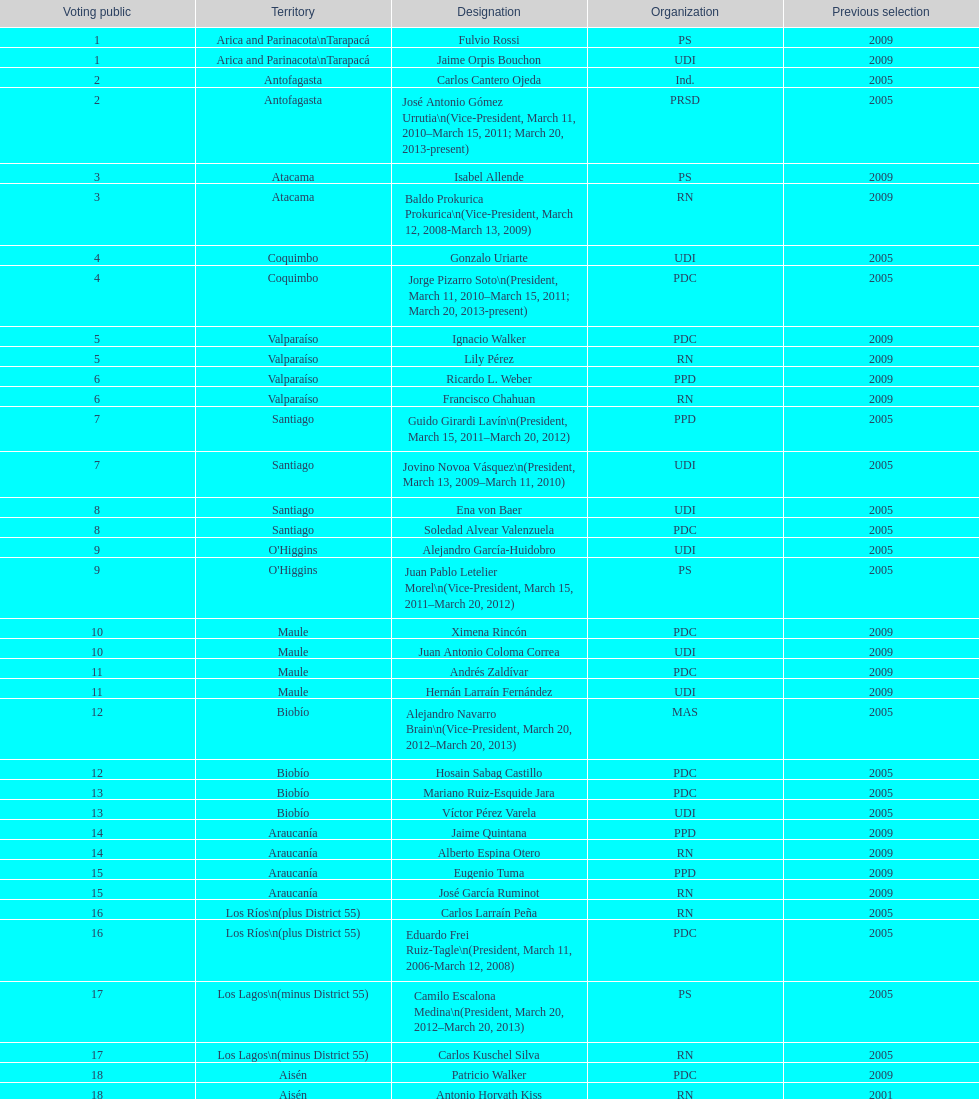Parse the full table. {'header': ['Voting public', 'Territory', 'Designation', 'Organization', 'Previous selection'], 'rows': [['1', 'Arica and Parinacota\\nTarapacá', 'Fulvio Rossi', 'PS', '2009'], ['1', 'Arica and Parinacota\\nTarapacá', 'Jaime Orpis Bouchon', 'UDI', '2009'], ['2', 'Antofagasta', 'Carlos Cantero Ojeda', 'Ind.', '2005'], ['2', 'Antofagasta', 'José Antonio Gómez Urrutia\\n(Vice-President, March 11, 2010–March 15, 2011; March 20, 2013-present)', 'PRSD', '2005'], ['3', 'Atacama', 'Isabel Allende', 'PS', '2009'], ['3', 'Atacama', 'Baldo Prokurica Prokurica\\n(Vice-President, March 12, 2008-March 13, 2009)', 'RN', '2009'], ['4', 'Coquimbo', 'Gonzalo Uriarte', 'UDI', '2005'], ['4', 'Coquimbo', 'Jorge Pizarro Soto\\n(President, March 11, 2010–March 15, 2011; March 20, 2013-present)', 'PDC', '2005'], ['5', 'Valparaíso', 'Ignacio Walker', 'PDC', '2009'], ['5', 'Valparaíso', 'Lily Pérez', 'RN', '2009'], ['6', 'Valparaíso', 'Ricardo L. Weber', 'PPD', '2009'], ['6', 'Valparaíso', 'Francisco Chahuan', 'RN', '2009'], ['7', 'Santiago', 'Guido Girardi Lavín\\n(President, March 15, 2011–March 20, 2012)', 'PPD', '2005'], ['7', 'Santiago', 'Jovino Novoa Vásquez\\n(President, March 13, 2009–March 11, 2010)', 'UDI', '2005'], ['8', 'Santiago', 'Ena von Baer', 'UDI', '2005'], ['8', 'Santiago', 'Soledad Alvear Valenzuela', 'PDC', '2005'], ['9', "O'Higgins", 'Alejandro García-Huidobro', 'UDI', '2005'], ['9', "O'Higgins", 'Juan Pablo Letelier Morel\\n(Vice-President, March 15, 2011–March 20, 2012)', 'PS', '2005'], ['10', 'Maule', 'Ximena Rincón', 'PDC', '2009'], ['10', 'Maule', 'Juan Antonio Coloma Correa', 'UDI', '2009'], ['11', 'Maule', 'Andrés Zaldívar', 'PDC', '2009'], ['11', 'Maule', 'Hernán Larraín Fernández', 'UDI', '2009'], ['12', 'Biobío', 'Alejandro Navarro Brain\\n(Vice-President, March 20, 2012–March 20, 2013)', 'MAS', '2005'], ['12', 'Biobío', 'Hosain Sabag Castillo', 'PDC', '2005'], ['13', 'Biobío', 'Mariano Ruiz-Esquide Jara', 'PDC', '2005'], ['13', 'Biobío', 'Víctor Pérez Varela', 'UDI', '2005'], ['14', 'Araucanía', 'Jaime Quintana', 'PPD', '2009'], ['14', 'Araucanía', 'Alberto Espina Otero', 'RN', '2009'], ['15', 'Araucanía', 'Eugenio Tuma', 'PPD', '2009'], ['15', 'Araucanía', 'José García Ruminot', 'RN', '2009'], ['16', 'Los Ríos\\n(plus District 55)', 'Carlos Larraín Peña', 'RN', '2005'], ['16', 'Los Ríos\\n(plus District 55)', 'Eduardo Frei Ruiz-Tagle\\n(President, March 11, 2006-March 12, 2008)', 'PDC', '2005'], ['17', 'Los Lagos\\n(minus District 55)', 'Camilo Escalona Medina\\n(President, March 20, 2012–March 20, 2013)', 'PS', '2005'], ['17', 'Los Lagos\\n(minus District 55)', 'Carlos Kuschel Silva', 'RN', '2005'], ['18', 'Aisén', 'Patricio Walker', 'PDC', '2009'], ['18', 'Aisén', 'Antonio Horvath Kiss', 'RN', '2001'], ['19', 'Magallanes', 'Carlos Bianchi Chelech\\n(Vice-President, March 13, 2009–March 11, 2010)', 'Ind.', '2005'], ['19', 'Magallanes', 'Pedro Muñoz Aburto', 'PS', '2005']]} How long was baldo prokurica prokurica vice-president? 1 year. 